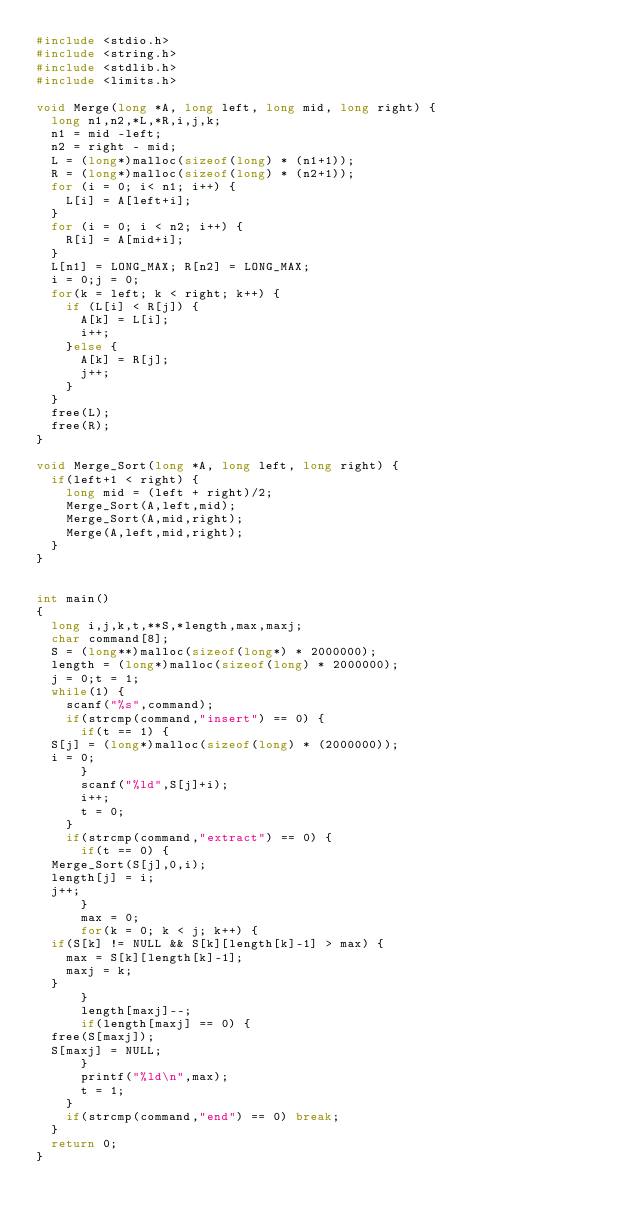Convert code to text. <code><loc_0><loc_0><loc_500><loc_500><_C_>#include <stdio.h>
#include <string.h>
#include <stdlib.h>
#include <limits.h>

void Merge(long *A, long left, long mid, long right) {
  long n1,n2,*L,*R,i,j,k;
  n1 = mid -left;
  n2 = right - mid;
  L = (long*)malloc(sizeof(long) * (n1+1));
  R = (long*)malloc(sizeof(long) * (n2+1));
  for (i = 0; i< n1; i++) {
    L[i] = A[left+i];
  }
  for (i = 0; i < n2; i++) {
    R[i] = A[mid+i];
  }
  L[n1] = LONG_MAX; R[n2] = LONG_MAX;
  i = 0;j = 0;
  for(k = left; k < right; k++) {
    if (L[i] < R[j]) {
      A[k] = L[i];
      i++;
    }else {
      A[k] = R[j];
      j++;
    }
  }
  free(L);
  free(R);
}

void Merge_Sort(long *A, long left, long right) {
  if(left+1 < right) {
    long mid = (left + right)/2;
    Merge_Sort(A,left,mid);
    Merge_Sort(A,mid,right);
    Merge(A,left,mid,right);
  }
}


int main()
{
  long i,j,k,t,**S,*length,max,maxj;
  char command[8];
  S = (long**)malloc(sizeof(long*) * 2000000);
  length = (long*)malloc(sizeof(long) * 2000000);
  j = 0;t = 1;
  while(1) {
    scanf("%s",command);
    if(strcmp(command,"insert") == 0) {
      if(t == 1) {
	S[j] = (long*)malloc(sizeof(long) * (2000000));
	i = 0;
      }
      scanf("%ld",S[j]+i);
      i++;
      t = 0;
    }
    if(strcmp(command,"extract") == 0) {
      if(t == 0) {
	Merge_Sort(S[j],0,i);
	length[j] = i;
	j++;
      }
      max = 0;
      for(k = 0; k < j; k++) {
	if(S[k] != NULL && S[k][length[k]-1] > max) {
	  max = S[k][length[k]-1];
	  maxj = k;
	}
      }
      length[maxj]--;
      if(length[maxj] == 0) {
	free(S[maxj]);
	S[maxj] = NULL;
      }
      printf("%ld\n",max);
      t = 1;
    }
    if(strcmp(command,"end") == 0) break;
  }
  return 0;
}</code> 